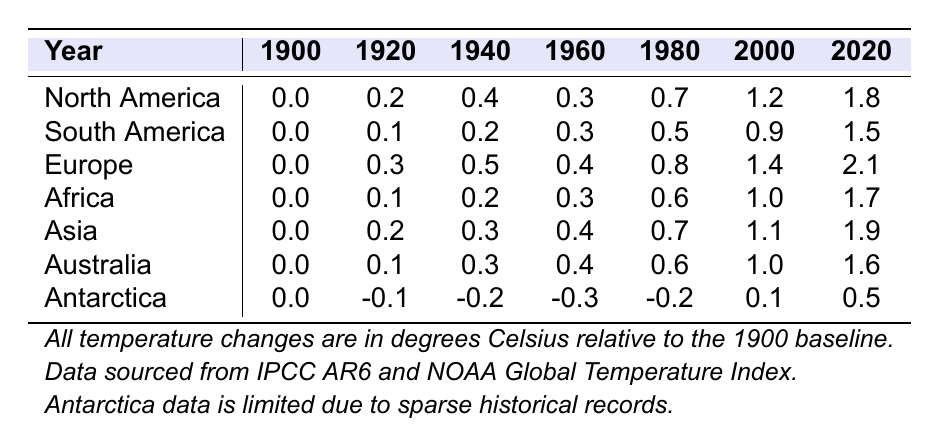What is the temperature change in Europe in 2020? Looking at the column for Europe in the row for 2020, the temperature change is 2.1 degrees Celsius.
Answer: 2.1 Which continent experienced the highest temperature change in 2000? In the year 2000, Europe shows a temperature change of 1.4 degrees Celsius, which is the highest compared to other continents listed.
Answer: Europe What was the temperature change in Antarctica in 1960? Referring to the row for Antarctica in the year 1960, the temperature change recorded is -0.3 degrees Celsius.
Answer: -0.3 Which continent had the least increase in temperature from 1900 to 2020? Analyzing the changes from 1900 to 2020, South America had an increase from 0.0 to 1.5 (1.5 degrees), while Antarctica had the least increase from 0.0 to 0.5 (0.5 degrees).
Answer: Antarctica How much did temperature change in Africa from 1980 to 2020? The temperature change for Africa in 1980 is 0.6 degrees Celsius, and in 2020 it is 1.7 degrees. We subtract to find the difference: 1.7 - 0.6 = 1.1 degrees Celsius.
Answer: 1.1 Did Asia experience more temperature change from 1900 to 2020 than North America? For Asia, the change from 1900 to 2020 is from 0.0 to 1.9 (1.9 degrees), while North America's change is from 0.0 to 1.8 (1.8 degrees). Since 1.9 > 1.8, Asia had more temperature change.
Answer: Yes What is the average temperature change for Europe across the years from 1900 to 2020? The temperature changes for Europe across the years are: 0.0, 0.3, 0.5, 0.4, 0.8, 1.4, 2.1. Adding these gives 0.0 + 0.3 + 0.5 + 0.4 + 0.8 + 1.4 + 2.1 = 5.6. There are 7 data points, so the average is 5.6 / 7 = 0.8 degrees Celsius.
Answer: 0.8 What was the largest temperature increase for any continent from 2000 to 2020? Analyzing the changes from 2000 to 2020: North America from 1.2 to 1.8 (0.6), South America from 0.9 to 1.5 (0.6), Europe from 1.4 to 2.1 (0.7), Africa from 1.0 to 1.7 (0.7), Asia from 1.1 to 1.9 (0.8), Australia from 1.0 to 1.6 (0.6), and Antarctica from 0.1 to 0.5 (0.4). The largest is Asia with an increase of 0.8 degrees Celsius.
Answer: Asia In which year did Africa show a temperature change of 0.3 degrees? Looking at the row for Africa, it shows a temperature change of 0.3 degrees in the years 1960 and 1980.
Answer: 1960 and 1980 